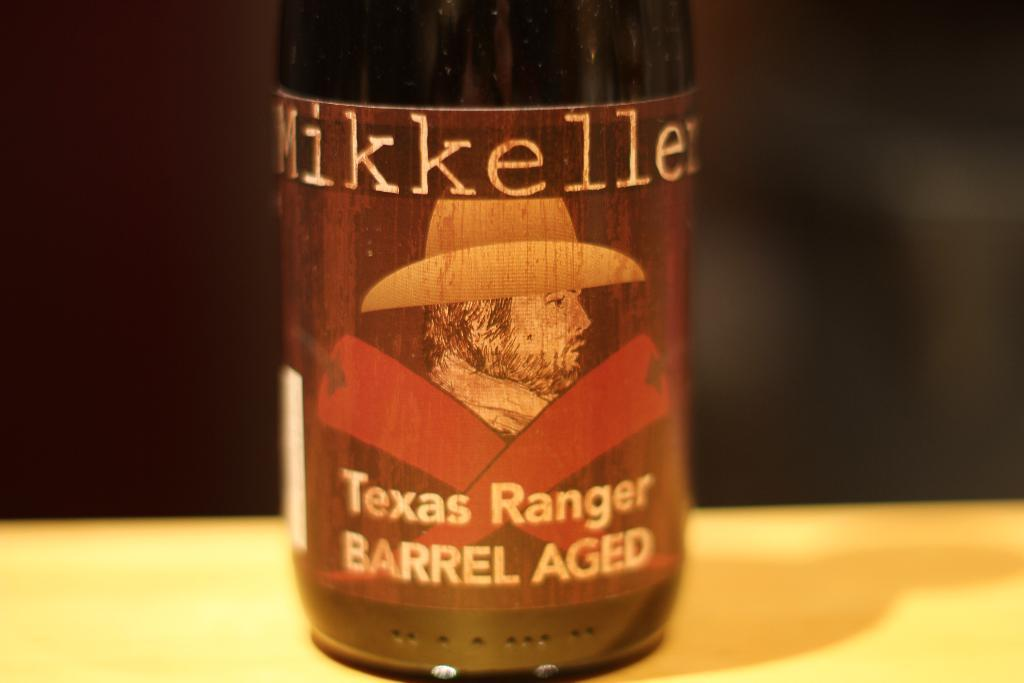<image>
Create a compact narrative representing the image presented. Bottle that has a cowboy and says Texas Ranger on it. 